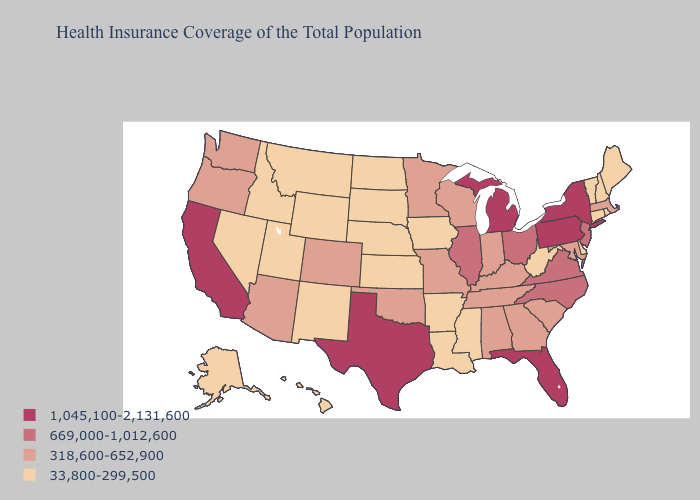Does the first symbol in the legend represent the smallest category?
Quick response, please. No. Does Vermont have the lowest value in the Northeast?
Keep it brief. Yes. Name the states that have a value in the range 669,000-1,012,600?
Write a very short answer. Illinois, New Jersey, North Carolina, Ohio, Virginia. What is the value of Virginia?
Write a very short answer. 669,000-1,012,600. Name the states that have a value in the range 1,045,100-2,131,600?
Quick response, please. California, Florida, Michigan, New York, Pennsylvania, Texas. Name the states that have a value in the range 1,045,100-2,131,600?
Concise answer only. California, Florida, Michigan, New York, Pennsylvania, Texas. Name the states that have a value in the range 33,800-299,500?
Short answer required. Alaska, Arkansas, Connecticut, Delaware, Hawaii, Idaho, Iowa, Kansas, Louisiana, Maine, Mississippi, Montana, Nebraska, Nevada, New Hampshire, New Mexico, North Dakota, Rhode Island, South Dakota, Utah, Vermont, West Virginia, Wyoming. Among the states that border North Dakota , which have the highest value?
Concise answer only. Minnesota. Does Missouri have a lower value than Ohio?
Answer briefly. Yes. What is the lowest value in the USA?
Answer briefly. 33,800-299,500. How many symbols are there in the legend?
Answer briefly. 4. Name the states that have a value in the range 669,000-1,012,600?
Short answer required. Illinois, New Jersey, North Carolina, Ohio, Virginia. Name the states that have a value in the range 669,000-1,012,600?
Write a very short answer. Illinois, New Jersey, North Carolina, Ohio, Virginia. Does Alabama have a lower value than Arizona?
Give a very brief answer. No. Among the states that border Tennessee , which have the highest value?
Answer briefly. North Carolina, Virginia. 